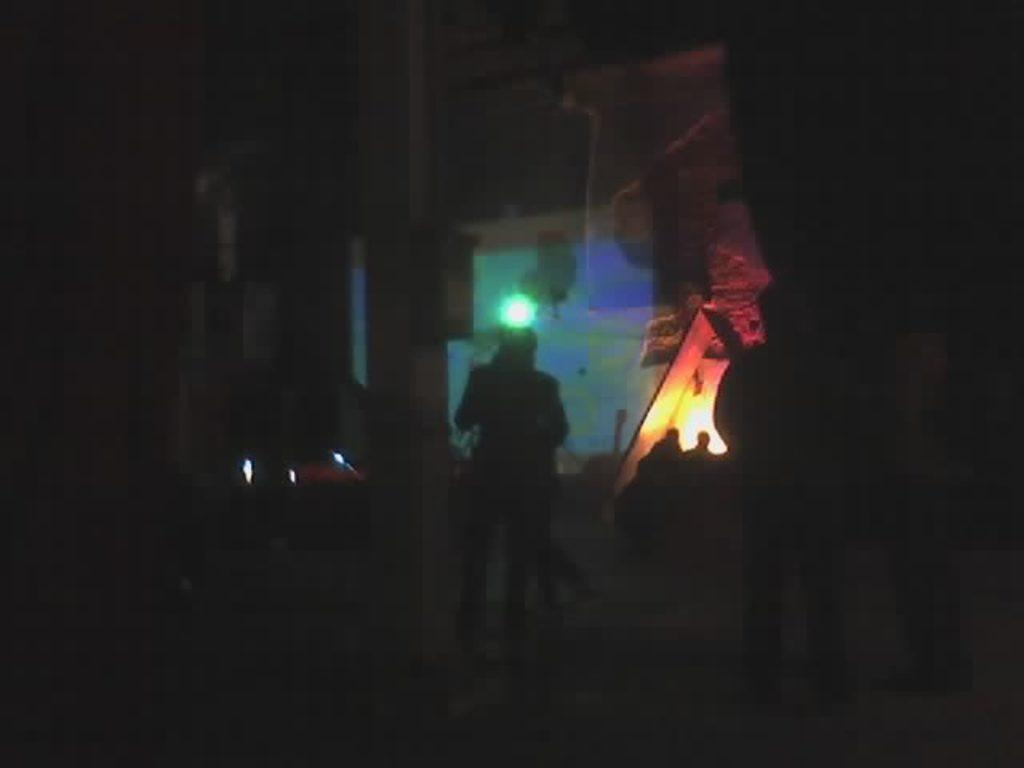What can be seen in the foreground of the image? There are people standing in the foreground of the image. What type of lighting is present in the image? There are color lights visible in the image. What type of selection is available for the giraffe in the image? There are no giraffes present in the image, so there is no selection available for a giraffe. 